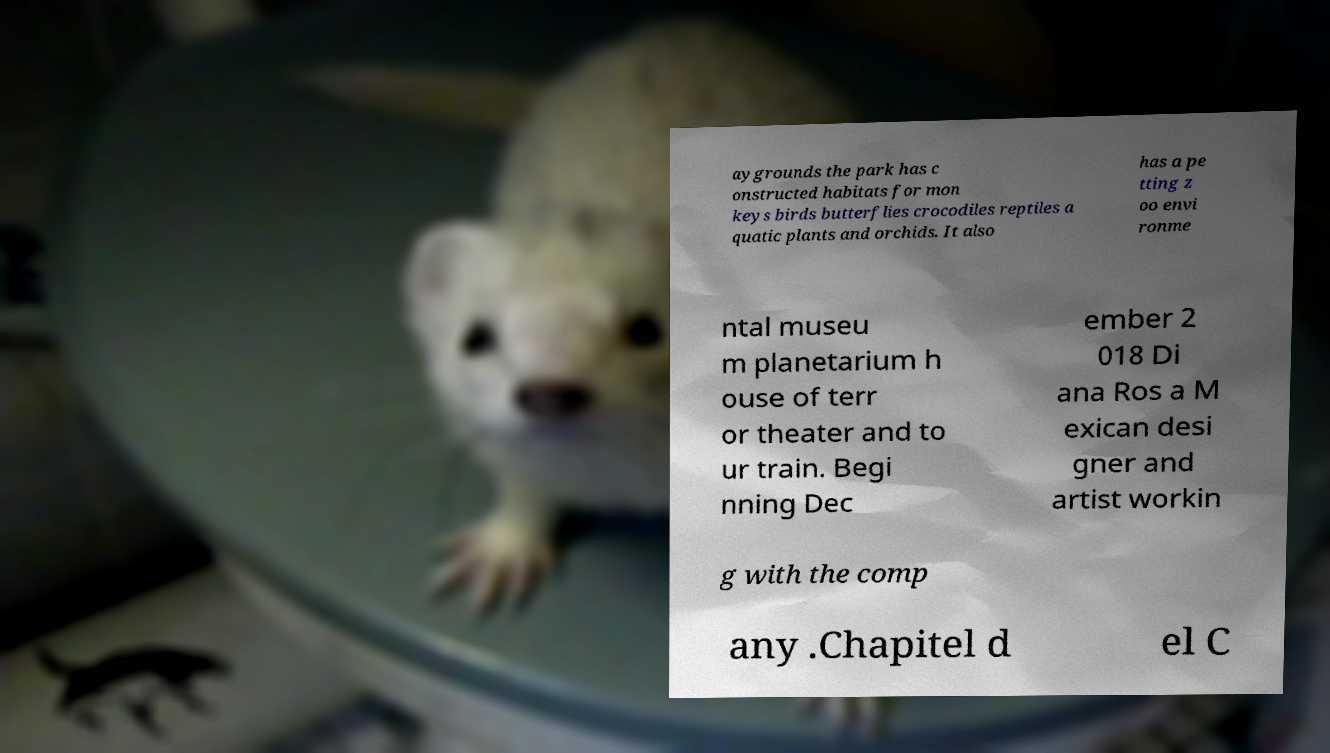Can you read and provide the text displayed in the image?This photo seems to have some interesting text. Can you extract and type it out for me? aygrounds the park has c onstructed habitats for mon keys birds butterflies crocodiles reptiles a quatic plants and orchids. It also has a pe tting z oo envi ronme ntal museu m planetarium h ouse of terr or theater and to ur train. Begi nning Dec ember 2 018 Di ana Ros a M exican desi gner and artist workin g with the comp any .Chapitel d el C 